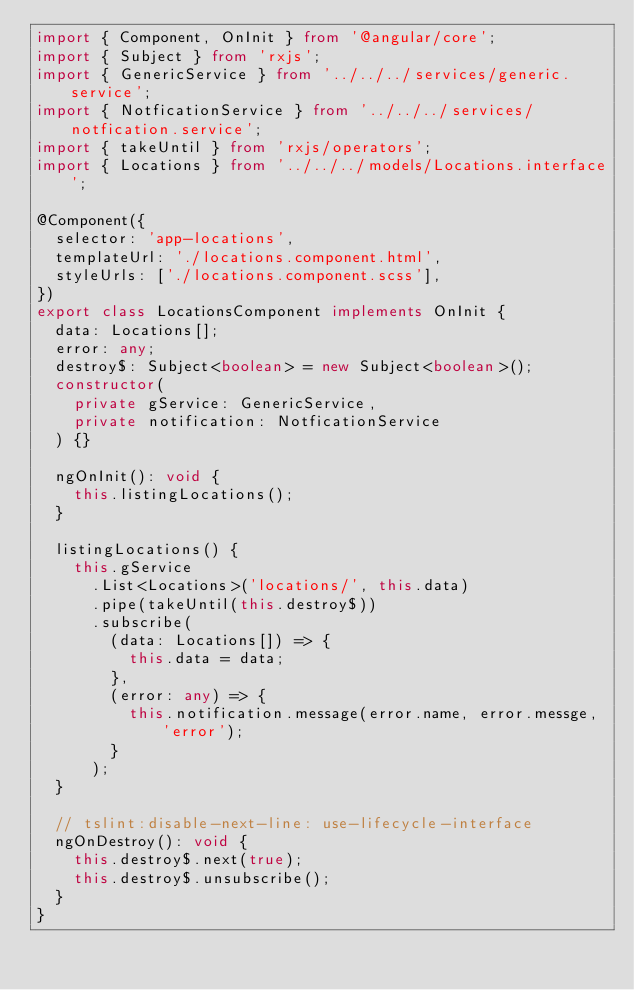<code> <loc_0><loc_0><loc_500><loc_500><_TypeScript_>import { Component, OnInit } from '@angular/core';
import { Subject } from 'rxjs';
import { GenericService } from '../../../services/generic.service';
import { NotficationService } from '../../../services/notfication.service';
import { takeUntil } from 'rxjs/operators';
import { Locations } from '../../../models/Locations.interface';

@Component({
  selector: 'app-locations',
  templateUrl: './locations.component.html',
  styleUrls: ['./locations.component.scss'],
})
export class LocationsComponent implements OnInit {
  data: Locations[];
  error: any;
  destroy$: Subject<boolean> = new Subject<boolean>();
  constructor(
    private gService: GenericService,
    private notification: NotficationService
  ) {}

  ngOnInit(): void {
    this.listingLocations();
  }

  listingLocations() {
    this.gService
      .List<Locations>('locations/', this.data)
      .pipe(takeUntil(this.destroy$))
      .subscribe(
        (data: Locations[]) => {
          this.data = data;
        },
        (error: any) => {
          this.notification.message(error.name, error.messge, 'error');
        }
      );
  }

  // tslint:disable-next-line: use-lifecycle-interface
  ngOnDestroy(): void {
    this.destroy$.next(true);
    this.destroy$.unsubscribe();
  }
}
</code> 